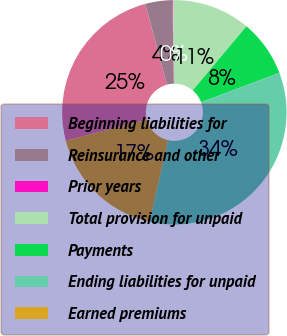Convert chart to OTSL. <chart><loc_0><loc_0><loc_500><loc_500><pie_chart><fcel>Beginning liabilities for<fcel>Reinsurance and other<fcel>Prior years<fcel>Total provision for unpaid<fcel>Payments<fcel>Ending liabilities for unpaid<fcel>Earned premiums<nl><fcel>24.92%<fcel>3.89%<fcel>0.09%<fcel>11.3%<fcel>8.18%<fcel>34.26%<fcel>17.37%<nl></chart> 